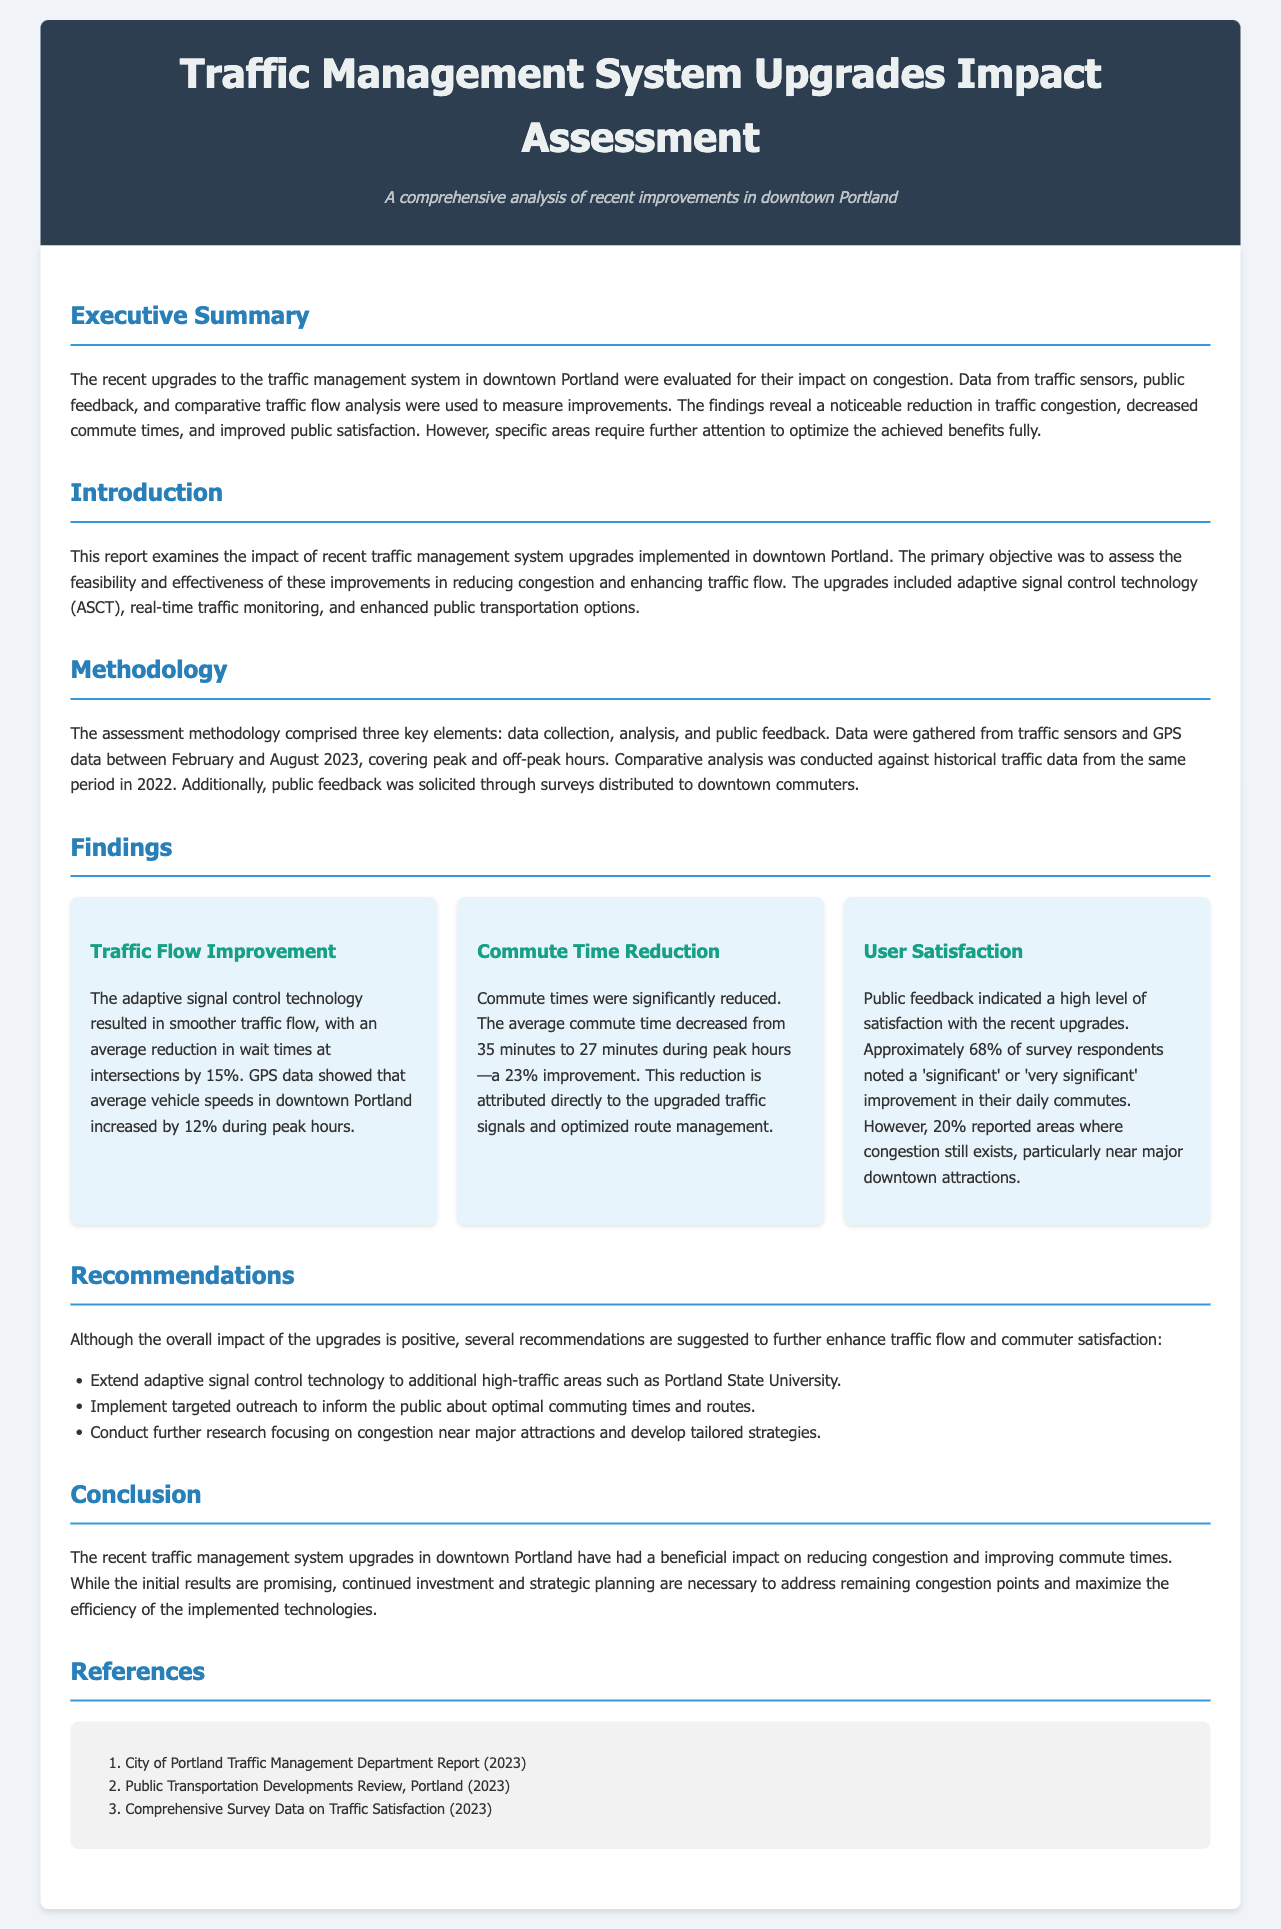What is the location of the assessed upgrades? The upgrades were implemented in downtown Portland, as stated in the introduction of the report.
Answer: downtown Portland What technology contributed to smoother traffic flow? The report highlights the adaptive signal control technology (ASCT) as the key contributor to improved traffic flow.
Answer: adaptive signal control technology (ASCT) What was the percentage reduction in average commute time? The findings state that the average commute time decreased by 23%, as shown in the commute time reduction section.
Answer: 23% What percentage of respondents noted a significant improvement in their daily commutes? The report indicates that approximately 68% of survey respondents reported a significant or very significant improvement, which is detailed under user satisfaction.
Answer: 68% What should be extended to high-traffic areas according to recommendations? The recommendations suggest extending the adaptive signal control technology to additional high-traffic areas, emphasizing strategic enhancements.
Answer: adaptive signal control technology 